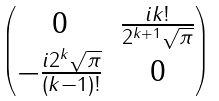Convert formula to latex. <formula><loc_0><loc_0><loc_500><loc_500>\begin{pmatrix} 0 & \frac { i k ! } { 2 ^ { k + 1 } \sqrt { \pi } } \\ - \frac { i 2 ^ { k } \sqrt { \pi } } { ( k - 1 ) ! } & 0 \end{pmatrix}</formula> 